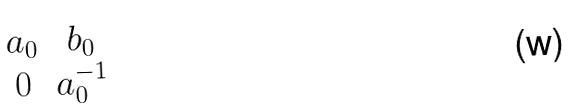Convert formula to latex. <formula><loc_0><loc_0><loc_500><loc_500>\begin{matrix} a _ { 0 } & b _ { 0 } \\ 0 & a _ { 0 } ^ { - 1 } \end{matrix}</formula> 